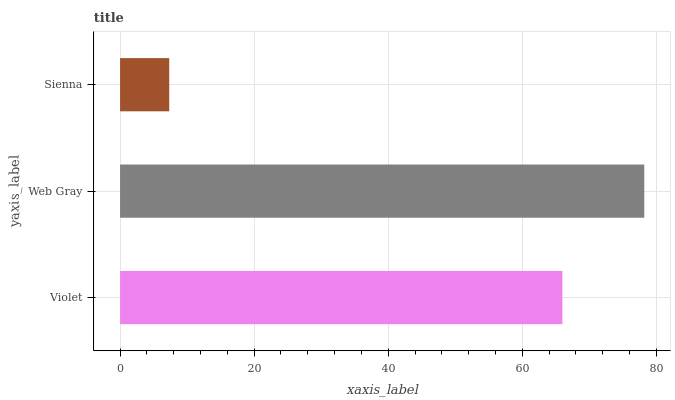Is Sienna the minimum?
Answer yes or no. Yes. Is Web Gray the maximum?
Answer yes or no. Yes. Is Web Gray the minimum?
Answer yes or no. No. Is Sienna the maximum?
Answer yes or no. No. Is Web Gray greater than Sienna?
Answer yes or no. Yes. Is Sienna less than Web Gray?
Answer yes or no. Yes. Is Sienna greater than Web Gray?
Answer yes or no. No. Is Web Gray less than Sienna?
Answer yes or no. No. Is Violet the high median?
Answer yes or no. Yes. Is Violet the low median?
Answer yes or no. Yes. Is Sienna the high median?
Answer yes or no. No. Is Web Gray the low median?
Answer yes or no. No. 